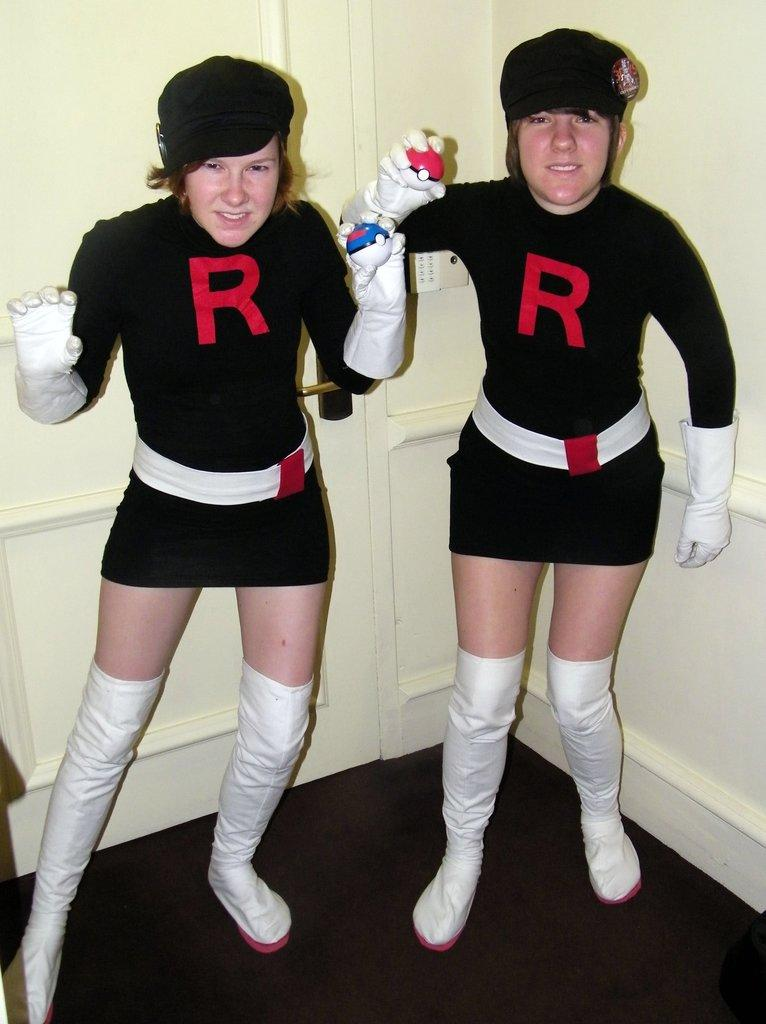<image>
Give a short and clear explanation of the subsequent image. A couple of girls posing beside each other wearing dresses with an R on it 